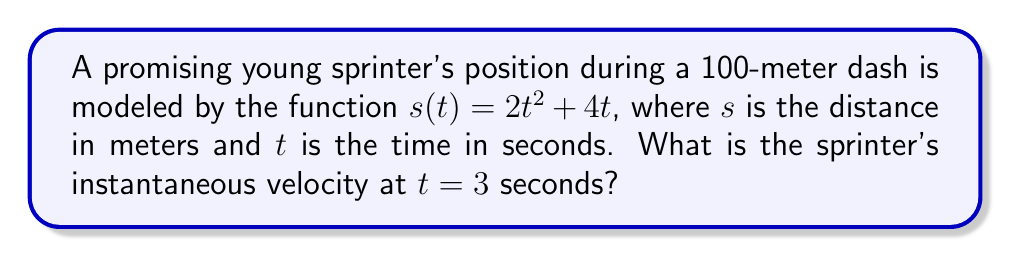Solve this math problem. To find the instantaneous velocity at a specific point, we need to calculate the derivative of the position function and evaluate it at the given time.

Step 1: Find the derivative of $s(t)$.
The position function is $s(t) = 2t^2 + 4t$
Using the power rule and constant multiple rule:
$s'(t) = 4t + 4$

Step 2: The derivative $s'(t)$ represents the velocity function $v(t)$.
$v(t) = 4t + 4$

Step 3: Evaluate the velocity function at $t = 3$ seconds.
$v(3) = 4(3) + 4$
$v(3) = 12 + 4 = 16$

Therefore, the sprinter's instantaneous velocity at $t = 3$ seconds is 16 meters per second.
Answer: 16 m/s 